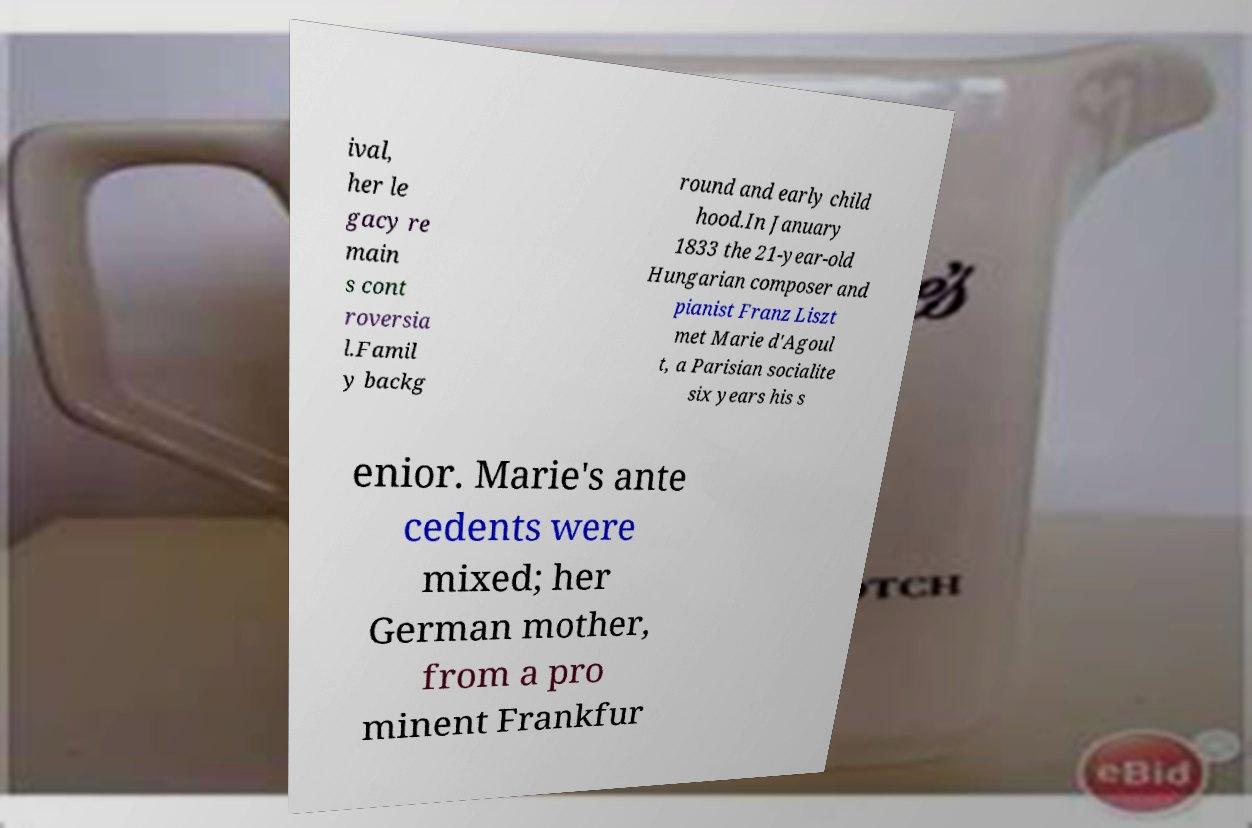I need the written content from this picture converted into text. Can you do that? ival, her le gacy re main s cont roversia l.Famil y backg round and early child hood.In January 1833 the 21-year-old Hungarian composer and pianist Franz Liszt met Marie d'Agoul t, a Parisian socialite six years his s enior. Marie's ante cedents were mixed; her German mother, from a pro minent Frankfur 